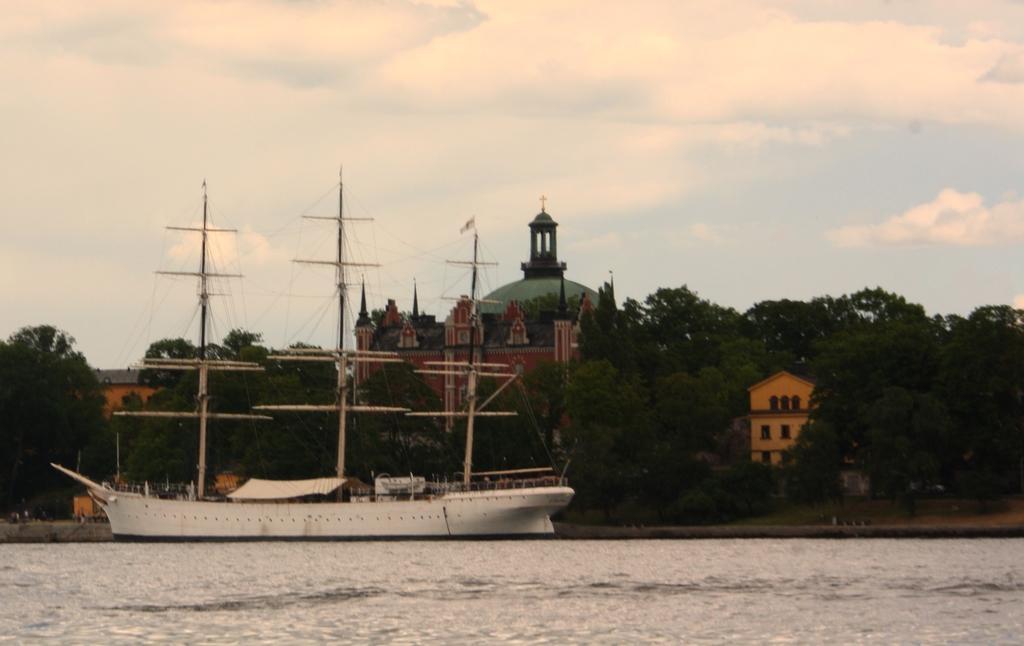Please provide a concise description of this image. In this image there is a ship on the river. In the background there are trees, buildings and the sky. 